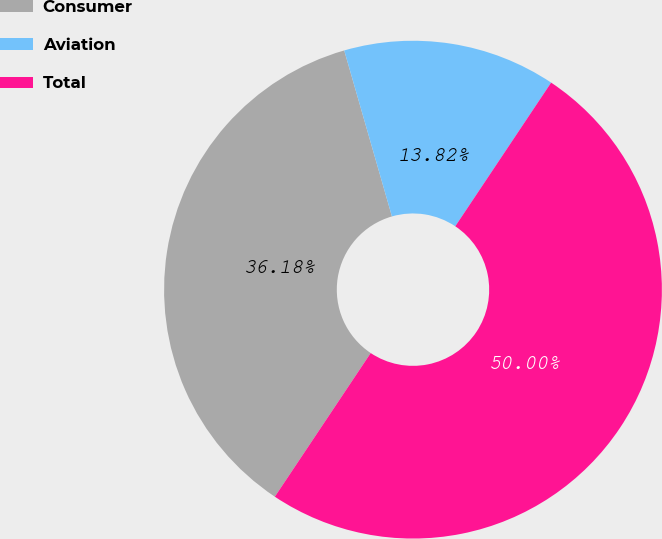<chart> <loc_0><loc_0><loc_500><loc_500><pie_chart><fcel>Consumer<fcel>Aviation<fcel>Total<nl><fcel>36.18%<fcel>13.82%<fcel>50.0%<nl></chart> 